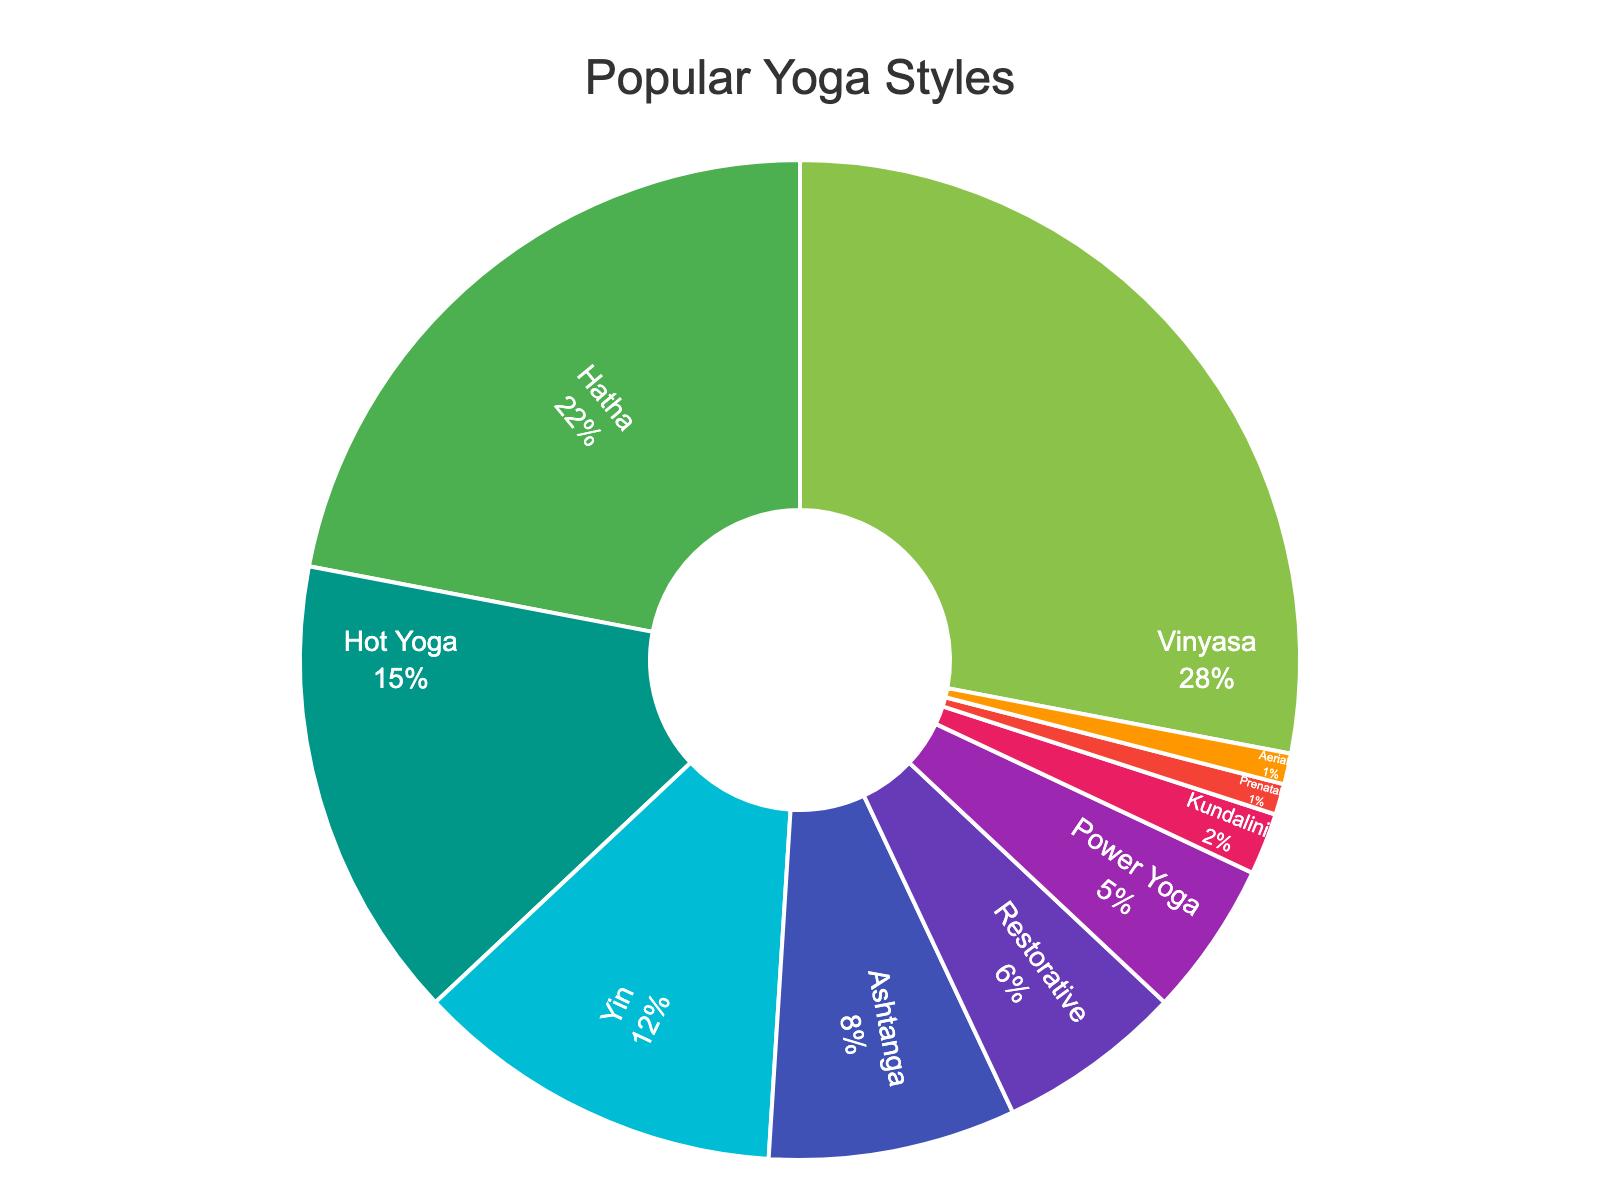Which yoga style is practiced the most by customers? The pie chart labels and percentages indicate that Vinyasa has the largest portion.
Answer: Vinyasa Which yoga style has the smallest percentage of customers? The pie chart labels and percentages show that both Prenatal and Aerial yoga styles are practiced by the smallest percentage.
Answer: Prenatal and Aerial What is the total percentage of customers practicing Vinyasa, Hatha, and Hot Yoga? Summing the percentages: Vinyasa (28%) + Hatha (22%) + Hot Yoga (15%) = 65%
Answer: 65% How much more popular is Vinyasa compared to Ashtanga? Vinyasa has 28% and Ashtanga has 8%. The difference is 28% - 8% = 20%.
Answer: 20% Which yoga styles together make up more than 50% of the customers? Adding the top styles until the sum exceeds 50%: Vinyasa (28%) + Hatha (22%) = 50%. Therefore, Vinyasa and Hatha together make up 50%.
Answer: Vinyasa and Hatha What percentage of customers practice eco-friendly styles like Restorative and Yin combined? Summing the percentages for Restorative (6%) and Yin (12%): 6% + 12% = 18%.
Answer: 18% Which style has a lower percentage, Kundalini or Power Yoga? From the chart, Kundalini has 2% and Power Yoga has 5%. Kundalini is lower.
Answer: Kundalini Are Hot Yoga and Ashtanga more popular than Hatha combined? Summing Hot Yoga and Ashtanga: 15% + 8% = 23%. Hatha is 22%. Therefore, Hot Yoga and Ashtanga combined is slightly more popular than Hatha.
Answer: Yes What is the combined percentage of all less popular styles (10% or less)? Summing the percentages of less popular styles: Ashtanga (8%) + Restorative (6%) + Power Yoga (5%) + Kundalini (2%) + Prenatal (1%) + Aerial (1%) = 23%.
Answer: 23% 